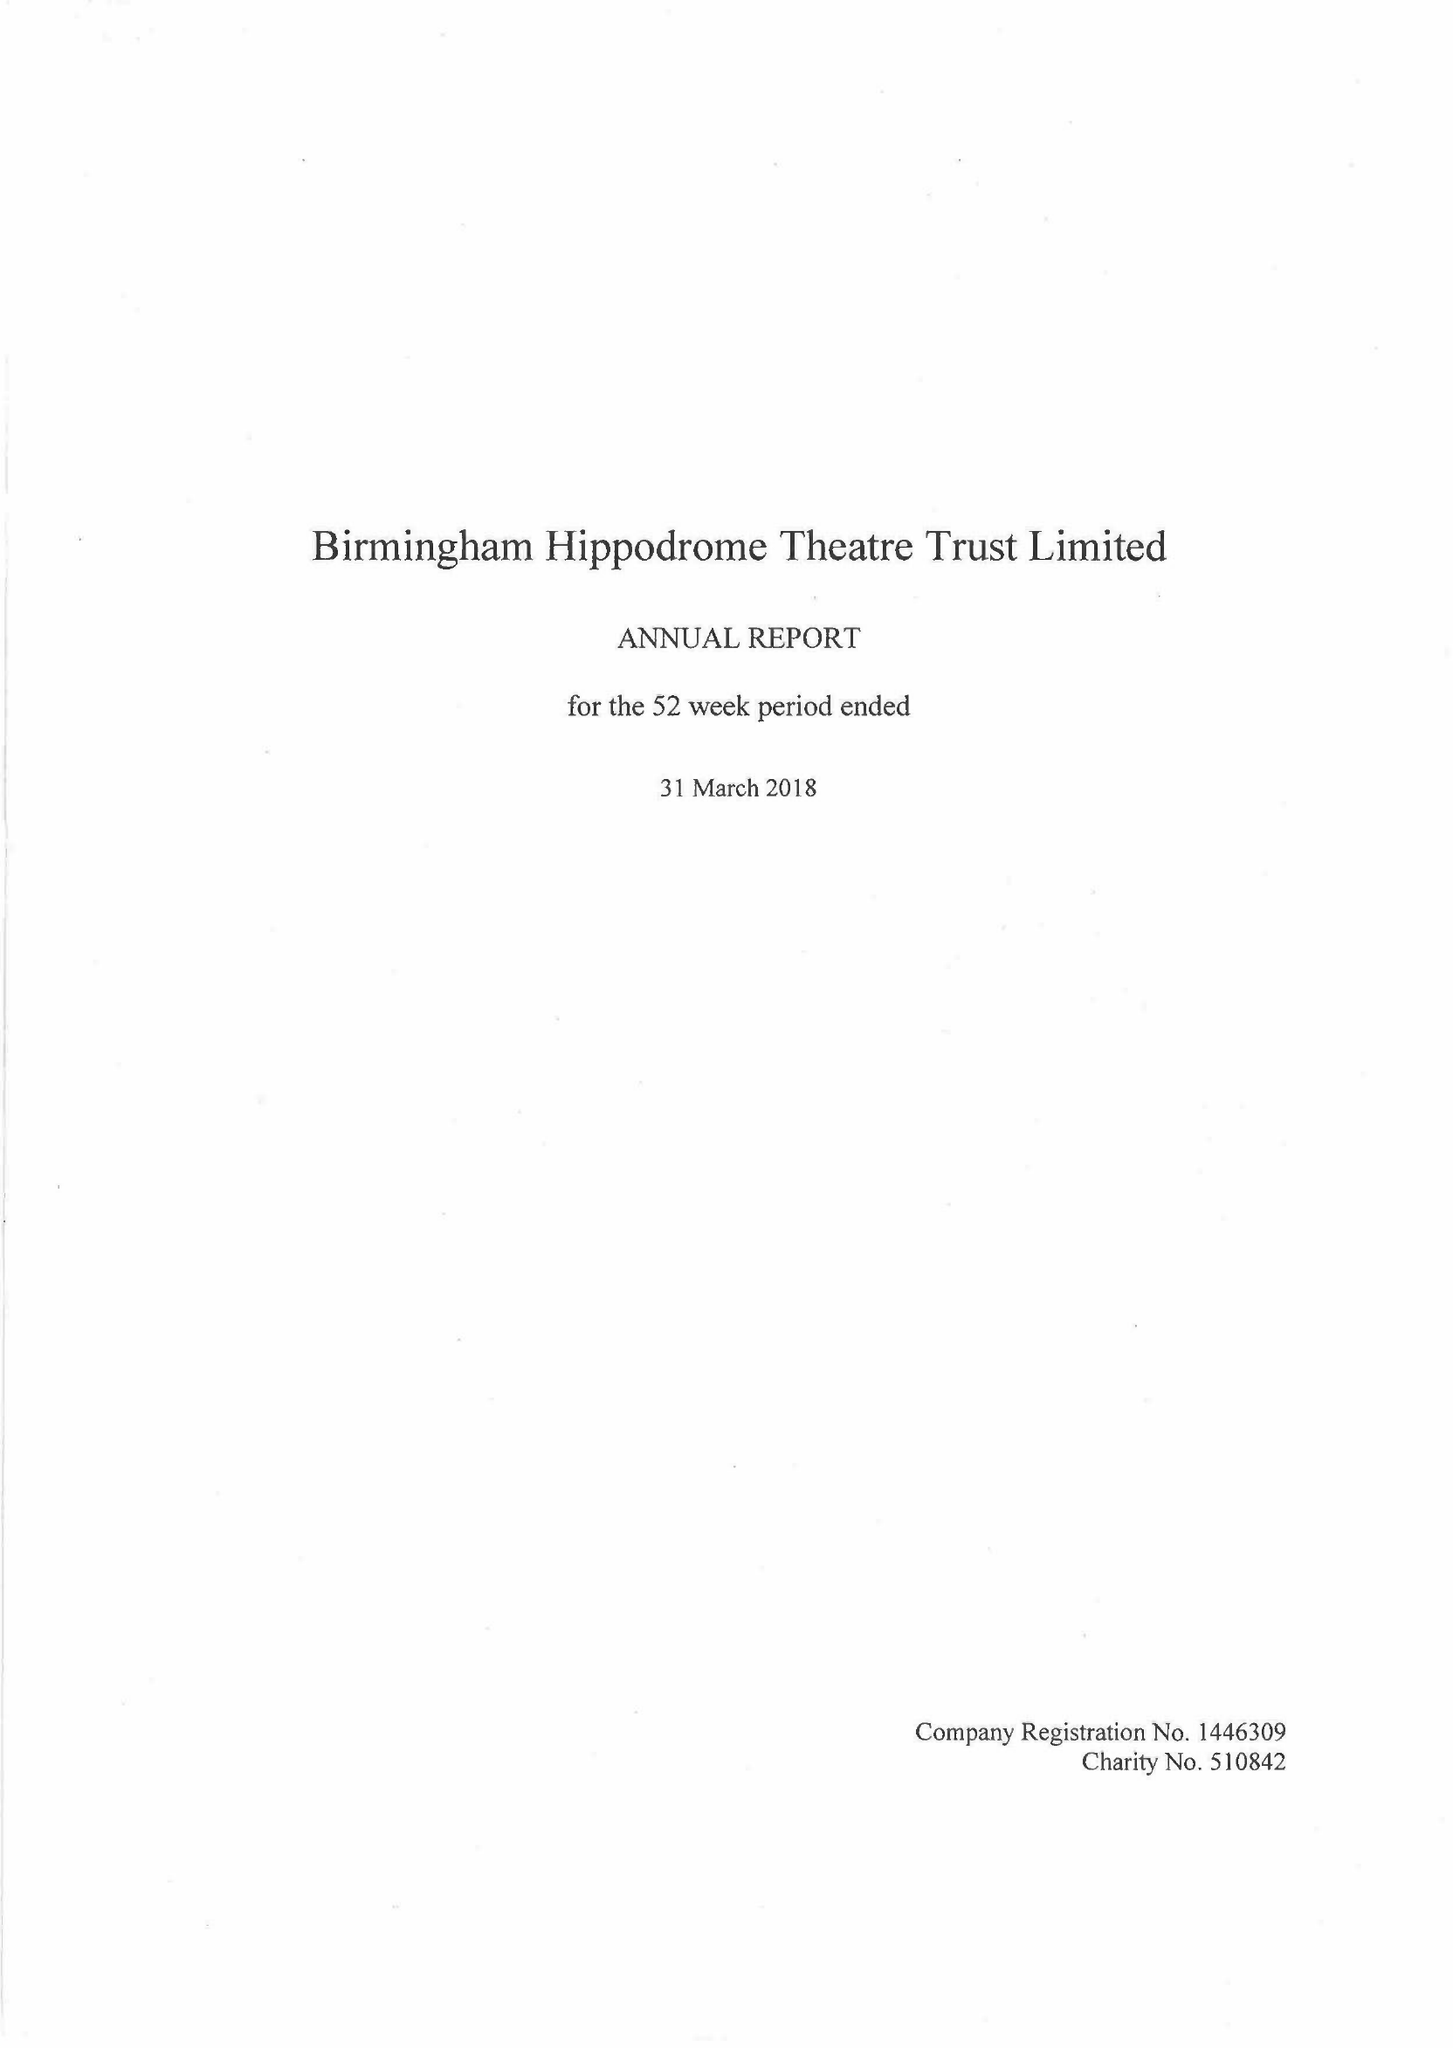What is the value for the address__postcode?
Answer the question using a single word or phrase. B5 4TB 